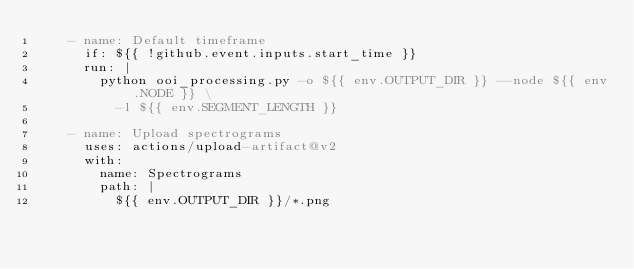Convert code to text. <code><loc_0><loc_0><loc_500><loc_500><_YAML_>    - name: Default timeframe
      if: ${{ !github.event.inputs.start_time }}
      run: |
        python ooi_processing.py -o ${{ env.OUTPUT_DIR }} --node ${{ env.NODE }} \
          -l ${{ env.SEGMENT_LENGTH }}

    - name: Upload spectrograms
      uses: actions/upload-artifact@v2
      with:
        name: Spectrograms
        path: |
          ${{ env.OUTPUT_DIR }}/*.png
</code> 